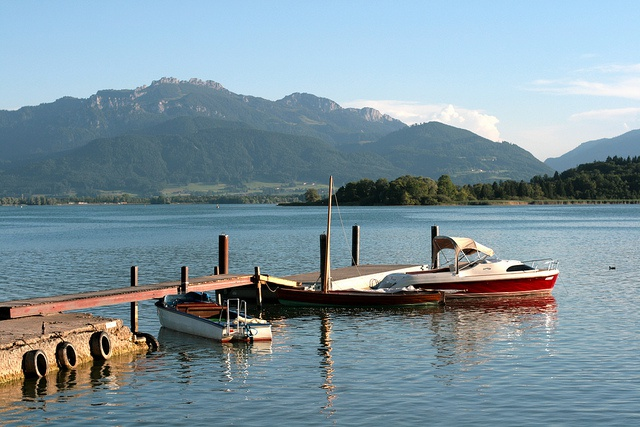Describe the objects in this image and their specific colors. I can see boat in lightblue, black, ivory, maroon, and darkgray tones, boat in lightblue, black, gray, maroon, and purple tones, and bird in lightblue, black, gray, and teal tones in this image. 